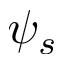<formula> <loc_0><loc_0><loc_500><loc_500>\psi _ { s }</formula> 